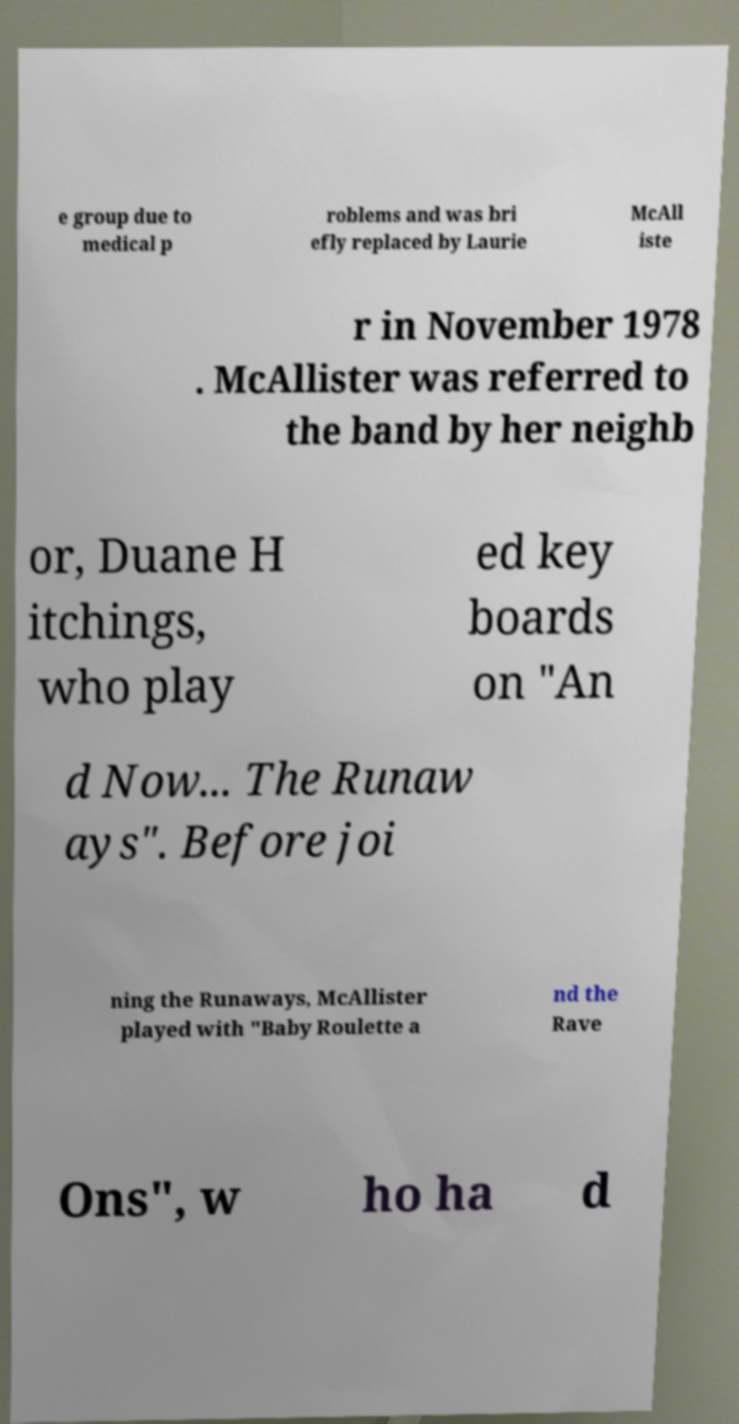Could you extract and type out the text from this image? e group due to medical p roblems and was bri efly replaced by Laurie McAll iste r in November 1978 . McAllister was referred to the band by her neighb or, Duane H itchings, who play ed key boards on "An d Now... The Runaw ays". Before joi ning the Runaways, McAllister played with "Baby Roulette a nd the Rave Ons", w ho ha d 